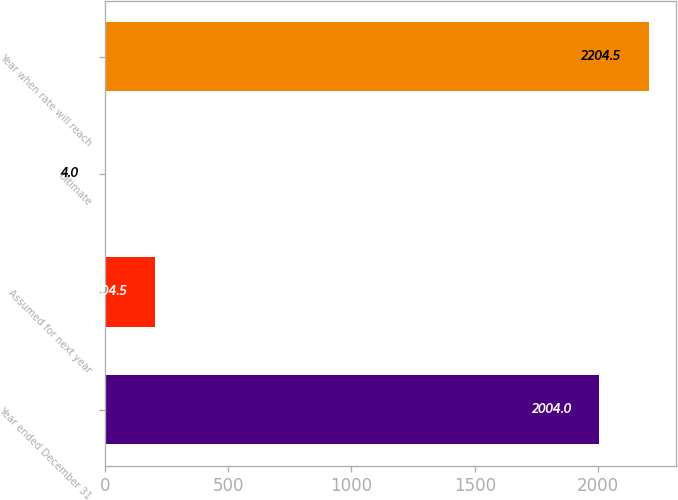<chart> <loc_0><loc_0><loc_500><loc_500><bar_chart><fcel>Year ended December 31<fcel>Assumed for next year<fcel>Ultimate<fcel>Year when rate will reach<nl><fcel>2004<fcel>204.5<fcel>4<fcel>2204.5<nl></chart> 